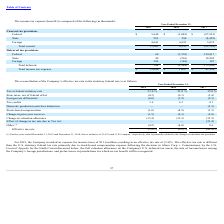According to Fitbit's financial document, What is the income tax expense for 2019? According to the financial document, $11.6 million. The relevant text states: "he Company recorded an expense for income taxes of $11.6 million, resulting in an effective tax rate of (3.8)%. The effective tax rate is different..." Also, What are the years that have tax at federal statutory rate of 21.0%? The document shows two values: 2018 and 2019. From the document: "2019 2018 2017 2019 2018 2017..." Also, What is the effective tax rate in 2017? According to the financial document, (42.4)%. The relevant text states: "Effective tax rate (3.8)% (0.9)% (42.4)%..." Also, can you calculate: What is the average tax at federal statutory rate from 2017-2019? To answer this question, I need to perform calculations using the financial data. The calculation is: (21.0+21.0+35.0)/3, which equals 25.67 (percentage). This is based on the information: "Tax at federal statutory rate 21.0 % 21.0 % 35.0 % Tax at federal statutory rate 21.0 % 21.0 % 35.0 %..." The key data points involved are: 21.0, 35.0. Also, can you calculate: What is the difference in tax credits between 2018 and 2019? Based on the calculation: 6.3-1.6, the result is 4.7 (percentage). This is based on the information: "Tax credits 1.6 6.3 4.1 Tax credits 1.6 6.3 4.1..." The key data points involved are: 1.6, 6.3. Also, can you calculate: What is the average tax credits from 2017-2019? To answer this question, I need to perform calculations using the financial data. The calculation is: (1.6+6.3+4.1)/3, which equals 4 (percentage). This is based on the information: "Tax credits 1.6 6.3 4.1 Tax credits 1.6 6.3 4.1 Tax credits 1.6 6.3 4.1..." The key data points involved are: 1.6, 4.1, 6.3. 